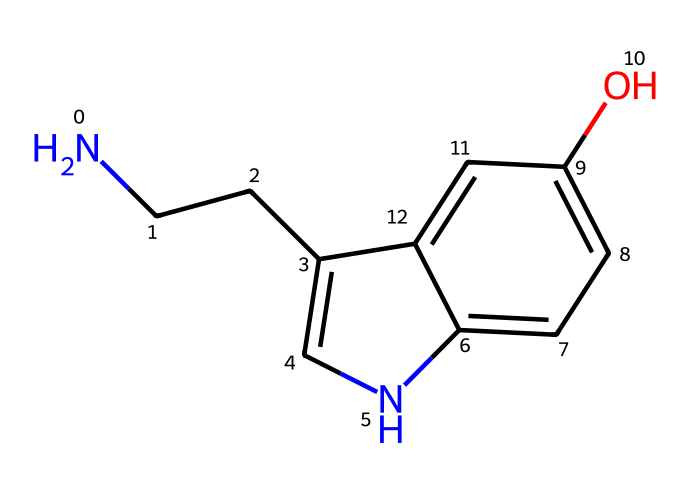What is the molecular formula of this compound? To determine the molecular formula, count the number of each type of atom in the SMILES representation. The SMILES "NCCc1c[nH]c2ccc(O)cc12" indicates there are 10 carbons (C), 12 hydrogens (H), 1 nitrogen (N), and 1 oxygen (O). Thus, the molecular formula is C10H12N2O.
Answer: C10H12N2O How many rings are present in this structure? Analyze the SMILES representation to identify rings. The notation "c" in the structure suggests aromatic carbon atoms. There are two fused cyclic structures visible in the representation. Therefore, we can confirm that this compound contains 2 rings.
Answer: 2 What role does the nitrogen atom play in this hormone? The presence of a nitrogen atom typically indicates the structure is likely an amine or an amine-containing compound, which contributes to the hormonal properties, specifically affecting neurotransmission. It is essential for forming the serotonin molecule and its functionality as a neurotransmitter.
Answer: neurotransmitter Which functional group is present in this structure? Look for specific groups indicated in the SMILES. The "O" suggests the presence of a hydroxyl (-OH) group, which is characteristic of phenolic compounds. The oxygen is attached to one of the carbon atoms in an aromatic ring, confirming the presence of a phenol functional group.
Answer: hydroxyl Is this compound classified as a hormone? Based on the definition of hormones as signaling molecules in the body, serotonin is classified as a hormone. It functions in regulating mood, among other physiological processes.
Answer: yes 